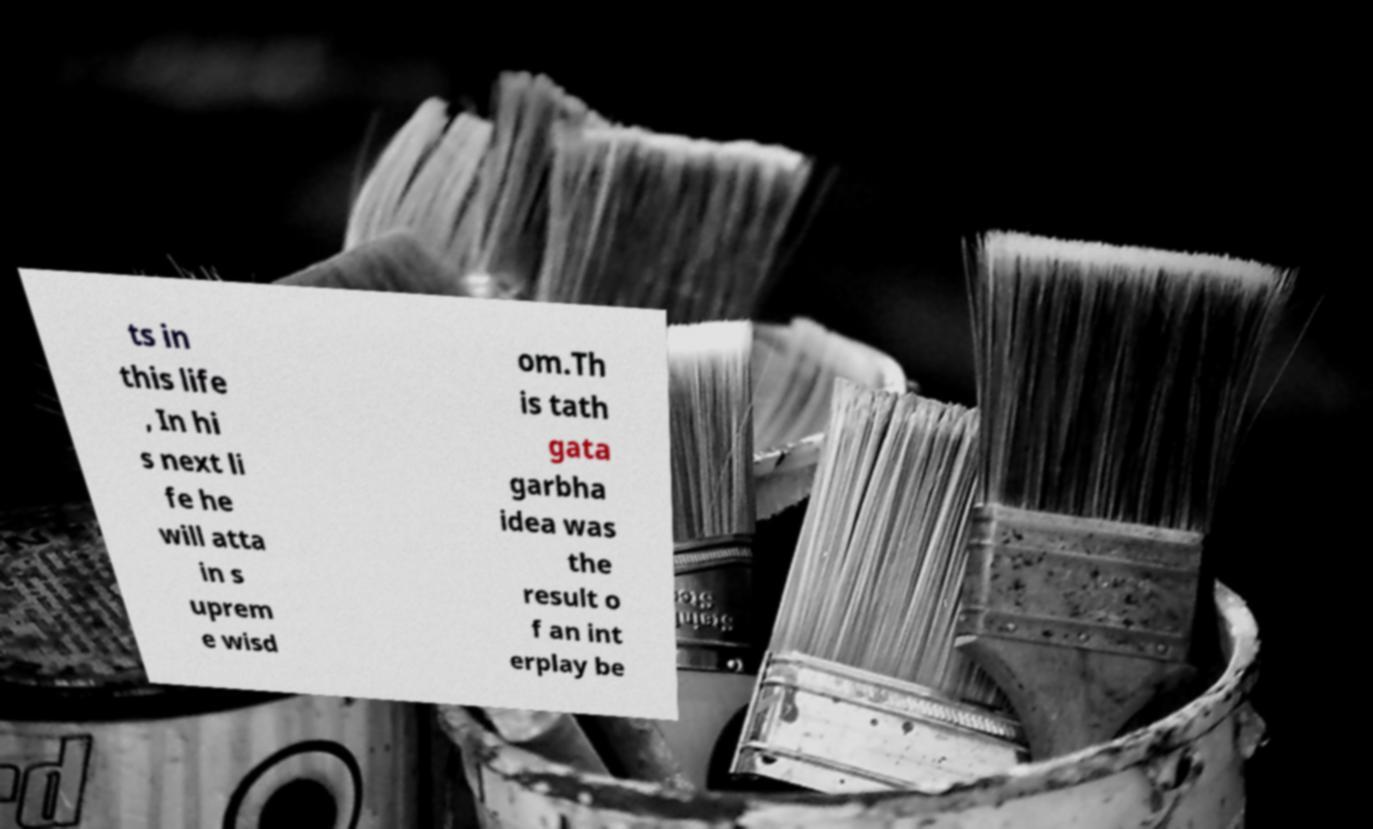There's text embedded in this image that I need extracted. Can you transcribe it verbatim? ts in this life , In hi s next li fe he will atta in s uprem e wisd om.Th is tath gata garbha idea was the result o f an int erplay be 